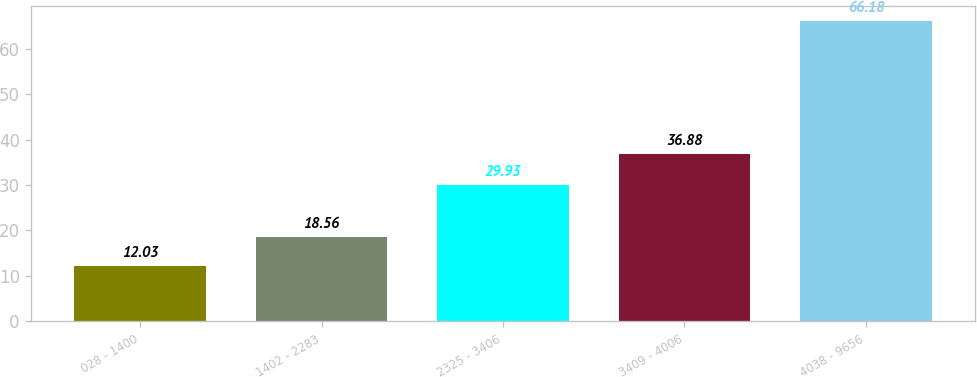<chart> <loc_0><loc_0><loc_500><loc_500><bar_chart><fcel>028 - 1400<fcel>1402 - 2283<fcel>2325 - 3406<fcel>3409 - 4006<fcel>4038 - 9656<nl><fcel>12.03<fcel>18.56<fcel>29.93<fcel>36.88<fcel>66.18<nl></chart> 